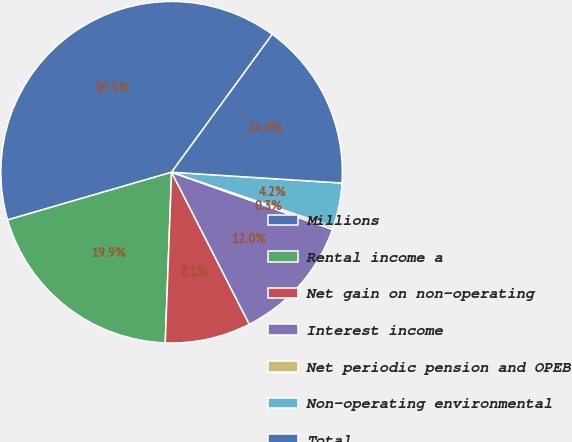Convert chart. <chart><loc_0><loc_0><loc_500><loc_500><pie_chart><fcel>Millions<fcel>Rental income a<fcel>Net gain on non-operating<fcel>Interest income<fcel>Net periodic pension and OPEB<fcel>Non-operating environmental<fcel>Total<nl><fcel>39.54%<fcel>19.9%<fcel>8.11%<fcel>12.04%<fcel>0.25%<fcel>4.18%<fcel>15.97%<nl></chart> 